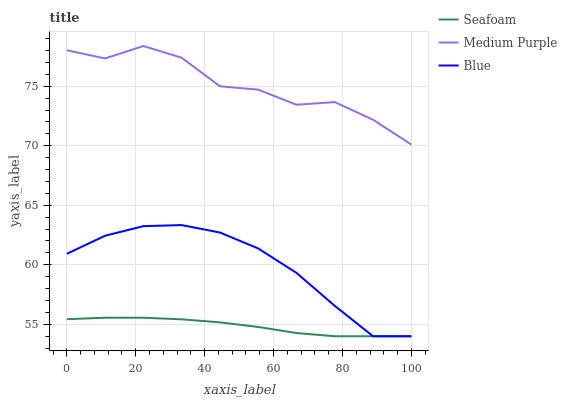Does Seafoam have the minimum area under the curve?
Answer yes or no. Yes. Does Medium Purple have the maximum area under the curve?
Answer yes or no. Yes. Does Blue have the minimum area under the curve?
Answer yes or no. No. Does Blue have the maximum area under the curve?
Answer yes or no. No. Is Seafoam the smoothest?
Answer yes or no. Yes. Is Medium Purple the roughest?
Answer yes or no. Yes. Is Blue the smoothest?
Answer yes or no. No. Is Blue the roughest?
Answer yes or no. No. Does Blue have the lowest value?
Answer yes or no. Yes. Does Medium Purple have the highest value?
Answer yes or no. Yes. Does Blue have the highest value?
Answer yes or no. No. Is Seafoam less than Medium Purple?
Answer yes or no. Yes. Is Medium Purple greater than Blue?
Answer yes or no. Yes. Does Blue intersect Seafoam?
Answer yes or no. Yes. Is Blue less than Seafoam?
Answer yes or no. No. Is Blue greater than Seafoam?
Answer yes or no. No. Does Seafoam intersect Medium Purple?
Answer yes or no. No. 